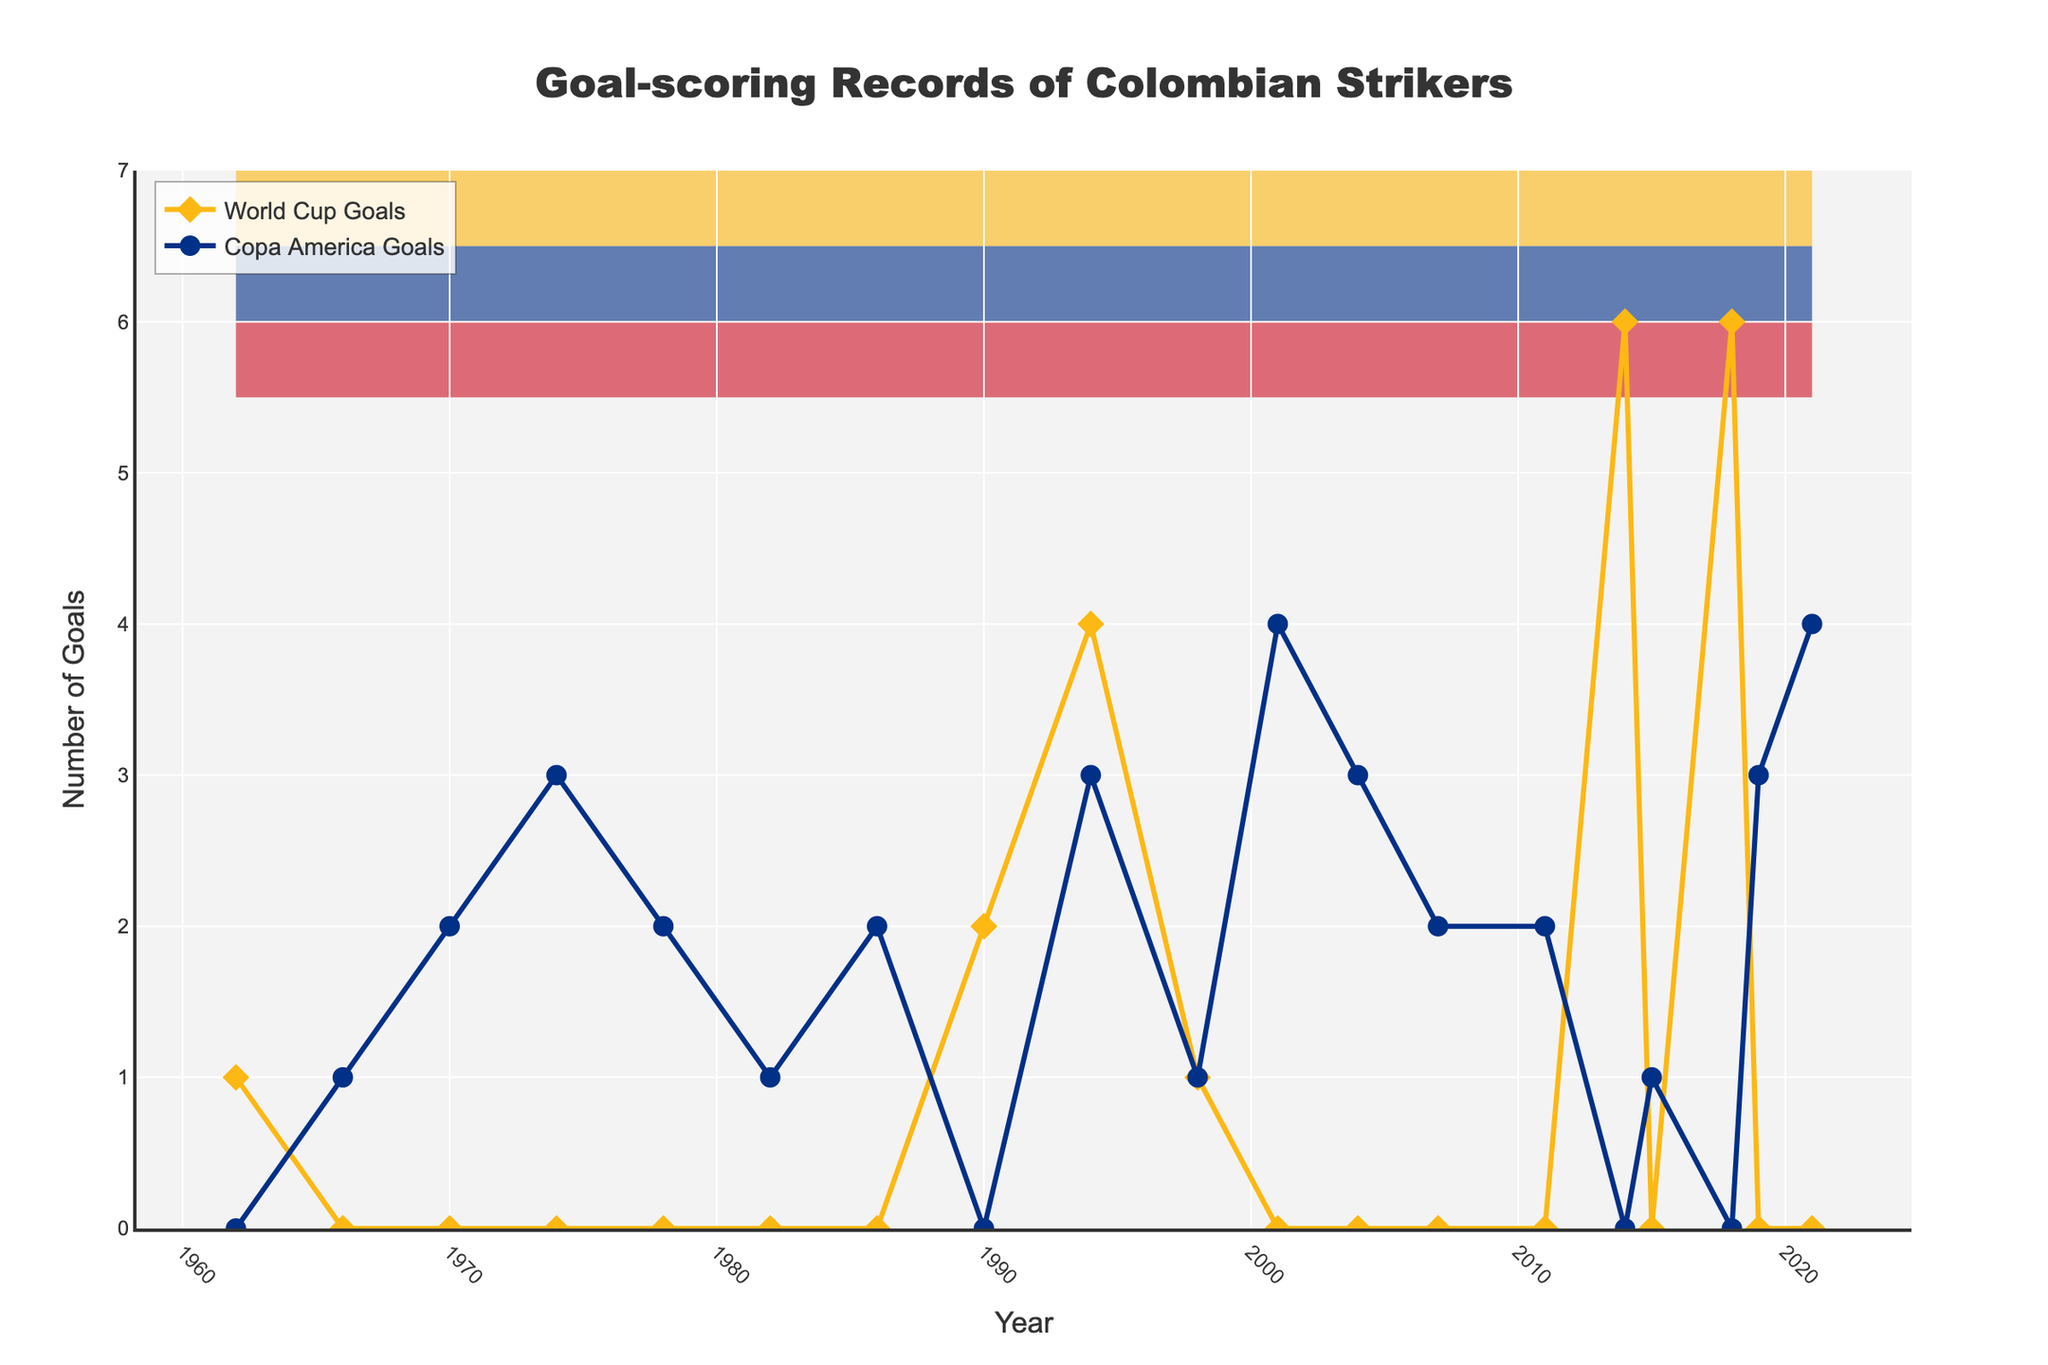What year did Colombian strikers score the most World Cup goals? Observe the World Cup Goals line and identify the highest peak. The peak is at 2014 and 2018, both with 6 goals.
Answer: 2014 and 2018 How many total goals did Colombian strikers score in the World Cup between 1990 and 1998? Sum the World Cup Goals for 1990, 1994, and 1998. The values are 2, 4, and 1 respectively. Thus, the total is 2 + 4 + 1 = 7.
Answer: 7 In which tournament and year did Colombian strikers score exactly 4 goals? Inspect the chart for both World Cup and Copa America Goals lines. Colombian strikers scored 4 goals in the 1994 World Cup and in the 2001 and 2021 Copa America.
Answer: 1994 World Cup, 2001 Copa America, 2021 Copa America How does the number of goals scored in the Copa America in 1994 compare to the number in the 2001 Copa America? Identify the Copa America Goals for 1994 (3) and 2001 (4). Then compare 3 < 4.
Answer: 1994 has fewer goals than 2001 What is the total number of Copa America Goals scored in the years where World Cup goals were zero? Sum Copa America goals in years where World Cup goals are zero. The relevant years and Copa America values are 1966 (1), 1970 (2), 1974 (3), 1978 (2), 1982 (1), 1986 (2), 2001 (4), 2004 (3), 2007 (2), 2011 (2), 2015 (1), and 2019 (3). The total is 26.
Answer: 26 Identify the longest period without World Cup goals and state its duration. Look for the longest time the 'World Cup Goals' line stays at zero. The gap is from 1966 to 1986, which is 6 tournaments or 20 years.
Answer: 20 years Which year had the highest combined total of World Cup and Copa America goals? Calculate the combined totals for each year and find the highest. 2014 has the highest combined total of 6 World Cup goals and 0 Copa America goals, summed to 6.
Answer: 2014 Were there any years where Colombian strikers scored more goals in the Copa America than in the World Cup? Provide one example. Compare goals scored in each tournament per year, and identify instances where Copa America goals exceed World Cup goals. For example, in 1974, Copa America goals (3) exceed World Cup goals (0).
Answer: 1974 How many more goals were scored by Colombian strikers in the 2018 World Cup compared to the 2014 World Cup? Identify the goals in both World Cups: 6 in 2018 and 6 in 2014. Subtract: 6 - 6 = 0.
Answer: 0 What trend can be observed in World Cup goal-scoring from 1990 to 2018? Observe the World Cup Goals line from 1990 to 2018. The trend is an overall increase, peaking at 6 in 2014 and 2018.
Answer: Increasing trend with peaks at 2014 and 2018 